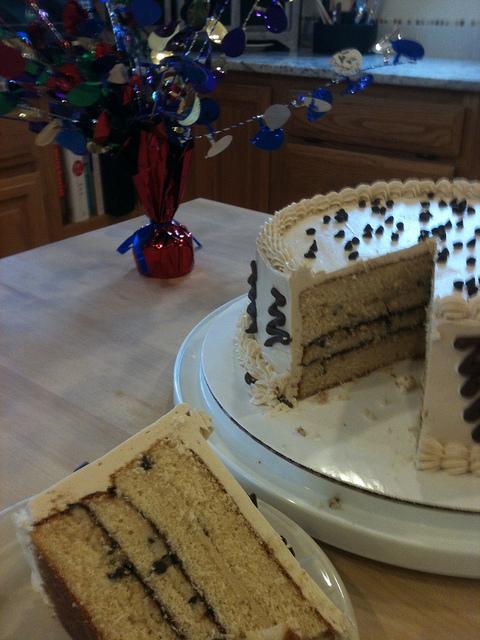What are they celebrating?
Be succinct. Birthday. What is coming out of the press?
Keep it brief. Cake. What kind of cake is that?
Quick response, please. White. What room is this picture taken in?
Be succinct. Kitchen. Has the cake been sliced?
Answer briefly. Yes. 